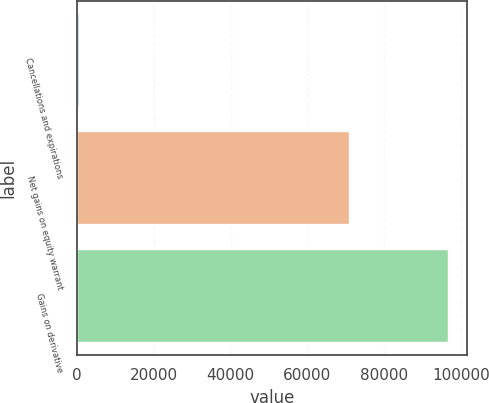Convert chart. <chart><loc_0><loc_0><loc_500><loc_500><bar_chart><fcel>Cancellations and expirations<fcel>Net gains on equity warrant<fcel>Gains on derivative<nl><fcel>856<fcel>71012<fcel>96845<nl></chart> 